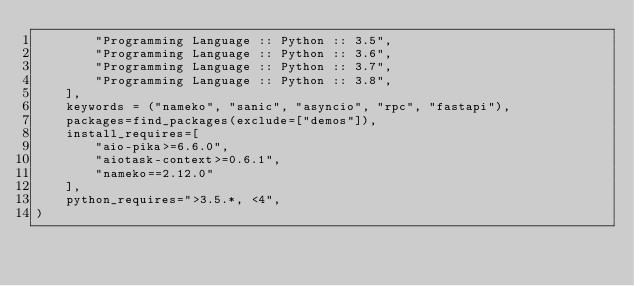<code> <loc_0><loc_0><loc_500><loc_500><_Python_>        "Programming Language :: Python :: 3.5",
        "Programming Language :: Python :: 3.6",
        "Programming Language :: Python :: 3.7",
        "Programming Language :: Python :: 3.8",
    ],
    keywords = ("nameko", "sanic", "asyncio", "rpc", "fastapi"),
    packages=find_packages(exclude=["demos"]),
    install_requires=[
        "aio-pika>=6.6.0",
        "aiotask-context>=0.6.1",
        "nameko==2.12.0"
    ],
    python_requires=">3.5.*, <4",
)
</code> 